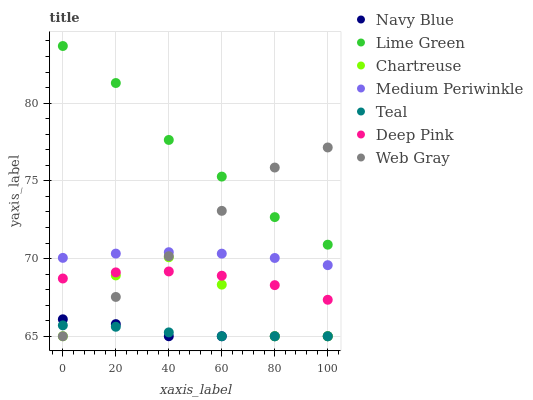Does Teal have the minimum area under the curve?
Answer yes or no. Yes. Does Lime Green have the maximum area under the curve?
Answer yes or no. Yes. Does Navy Blue have the minimum area under the curve?
Answer yes or no. No. Does Navy Blue have the maximum area under the curve?
Answer yes or no. No. Is Teal the smoothest?
Answer yes or no. Yes. Is Chartreuse the roughest?
Answer yes or no. Yes. Is Navy Blue the smoothest?
Answer yes or no. No. Is Navy Blue the roughest?
Answer yes or no. No. Does Navy Blue have the lowest value?
Answer yes or no. Yes. Does Medium Periwinkle have the lowest value?
Answer yes or no. No. Does Lime Green have the highest value?
Answer yes or no. Yes. Does Navy Blue have the highest value?
Answer yes or no. No. Is Chartreuse less than Lime Green?
Answer yes or no. Yes. Is Lime Green greater than Deep Pink?
Answer yes or no. Yes. Does Web Gray intersect Lime Green?
Answer yes or no. Yes. Is Web Gray less than Lime Green?
Answer yes or no. No. Is Web Gray greater than Lime Green?
Answer yes or no. No. Does Chartreuse intersect Lime Green?
Answer yes or no. No. 